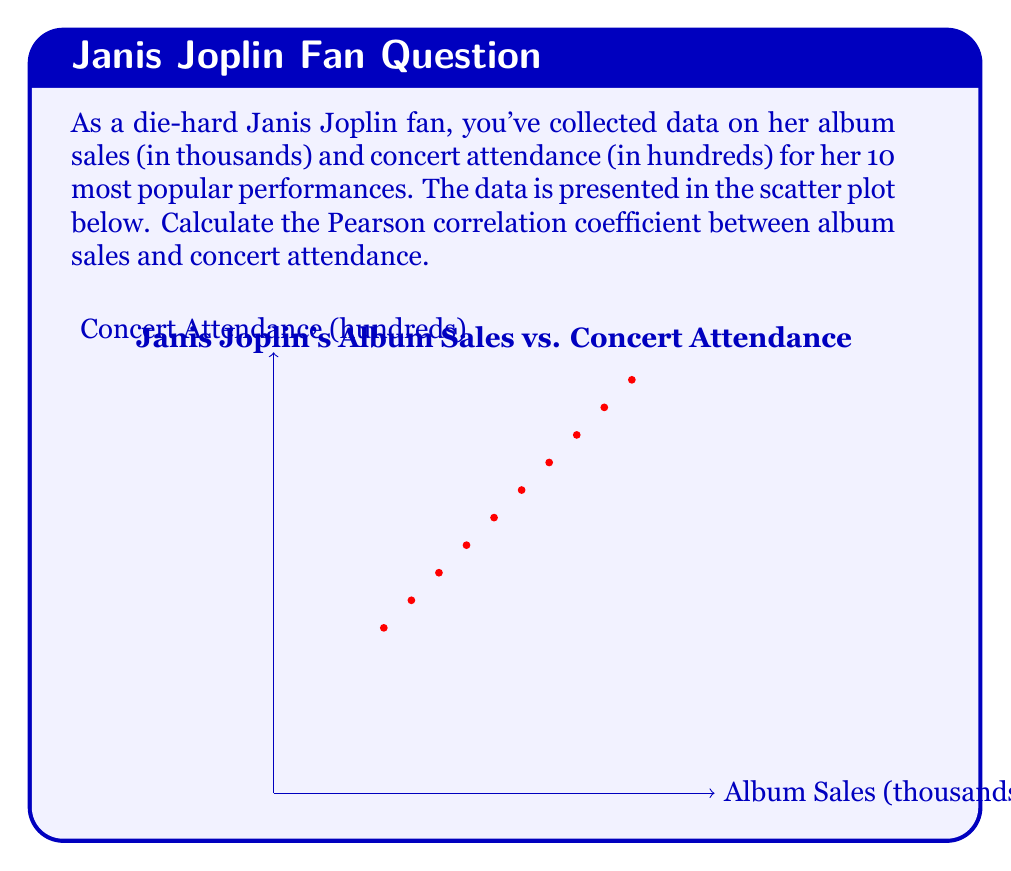Show me your answer to this math problem. To calculate the Pearson correlation coefficient (r), we'll use the formula:

$$r = \frac{\sum_{i=1}^{n} (x_i - \bar{x})(y_i - \bar{y})}{\sqrt{\sum_{i=1}^{n} (x_i - \bar{x})^2 \sum_{i=1}^{n} (y_i - \bar{y})^2}}$$

Where $x_i$ and $y_i$ are the individual sample points, and $\bar{x}$ and $\bar{y}$ are the means of x and y respectively.

Step 1: Calculate the means
$\bar{x} = \frac{20 + 25 + 30 + 35 + 40 + 45 + 50 + 55 + 60 + 65}{10} = 42.5$
$\bar{y} = \frac{30 + 35 + 40 + 45 + 50 + 55 + 60 + 65 + 70 + 75}{10} = 52.5$

Step 2: Calculate $(x_i - \bar{x})$, $(y_i - \bar{y})$, $(x_i - \bar{x})^2$, $(y_i - \bar{y})^2$, and $(x_i - \bar{x})(y_i - \bar{y})$ for each point

Step 3: Sum up the values calculated in Step 2
$\sum (x_i - \bar{x})(y_i - \bar{y}) = 2250$
$\sum (x_i - \bar{x})^2 = 2250$
$\sum (y_i - \bar{y})^2 = 2250$

Step 4: Plug these values into the correlation coefficient formula
$$r = \frac{2250}{\sqrt{2250 \cdot 2250}} = \frac{2250}{2250} = 1$$
Answer: $r = 1$ 